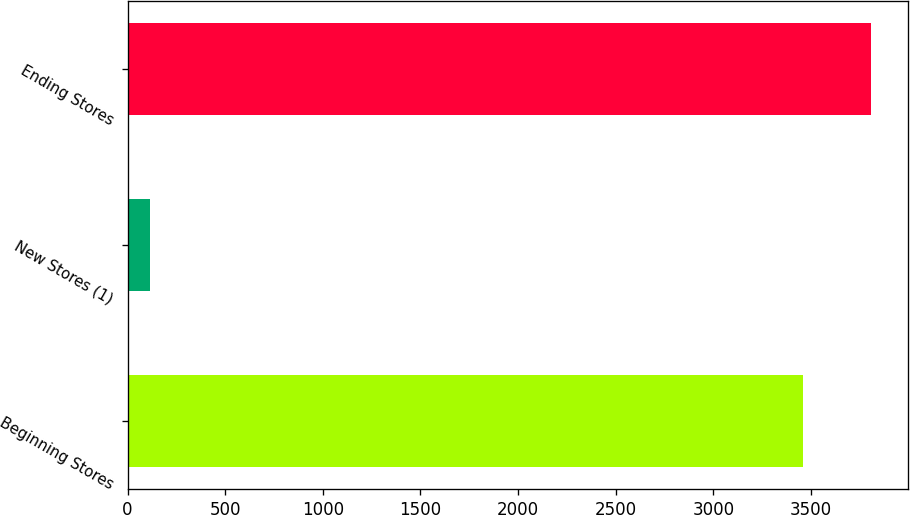Convert chart to OTSL. <chart><loc_0><loc_0><loc_500><loc_500><bar_chart><fcel>Beginning Stores<fcel>New Stores (1)<fcel>Ending Stores<nl><fcel>3460<fcel>116<fcel>3806<nl></chart> 